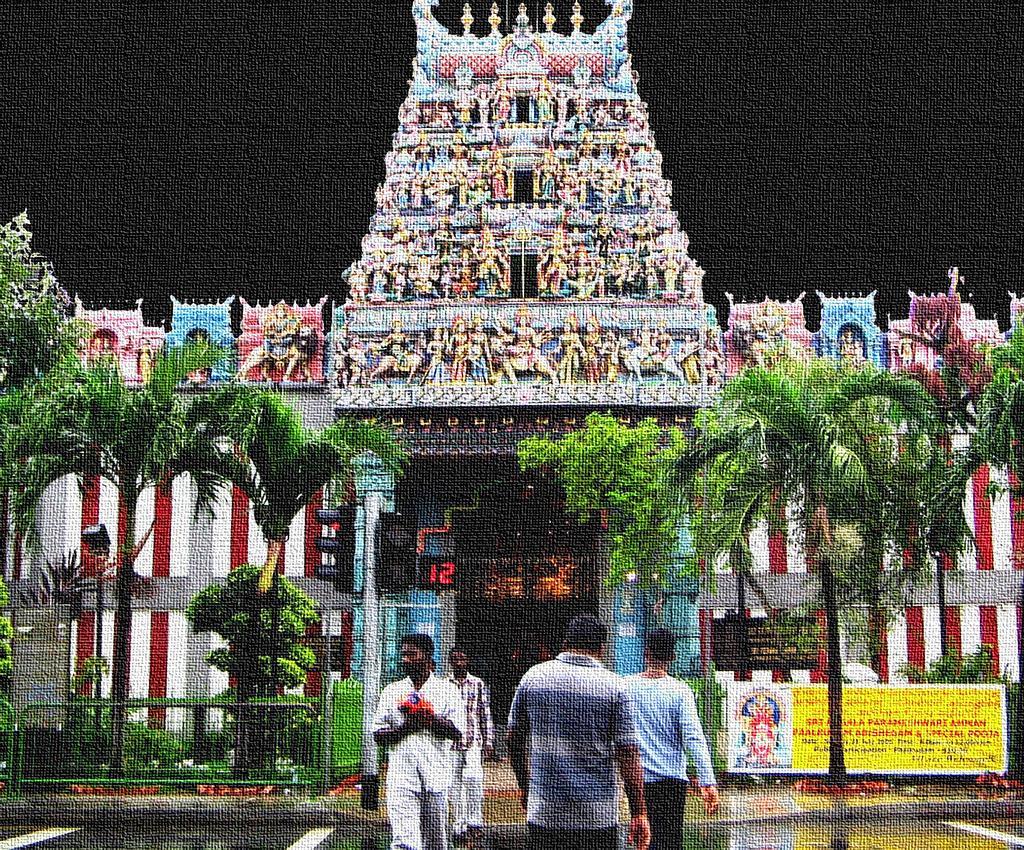Describe this image in one or two sentences. In this image, we can see few people, trees, banner, board, pole. Background we can see a temple arch and wall. Here we can see traffic signals. 